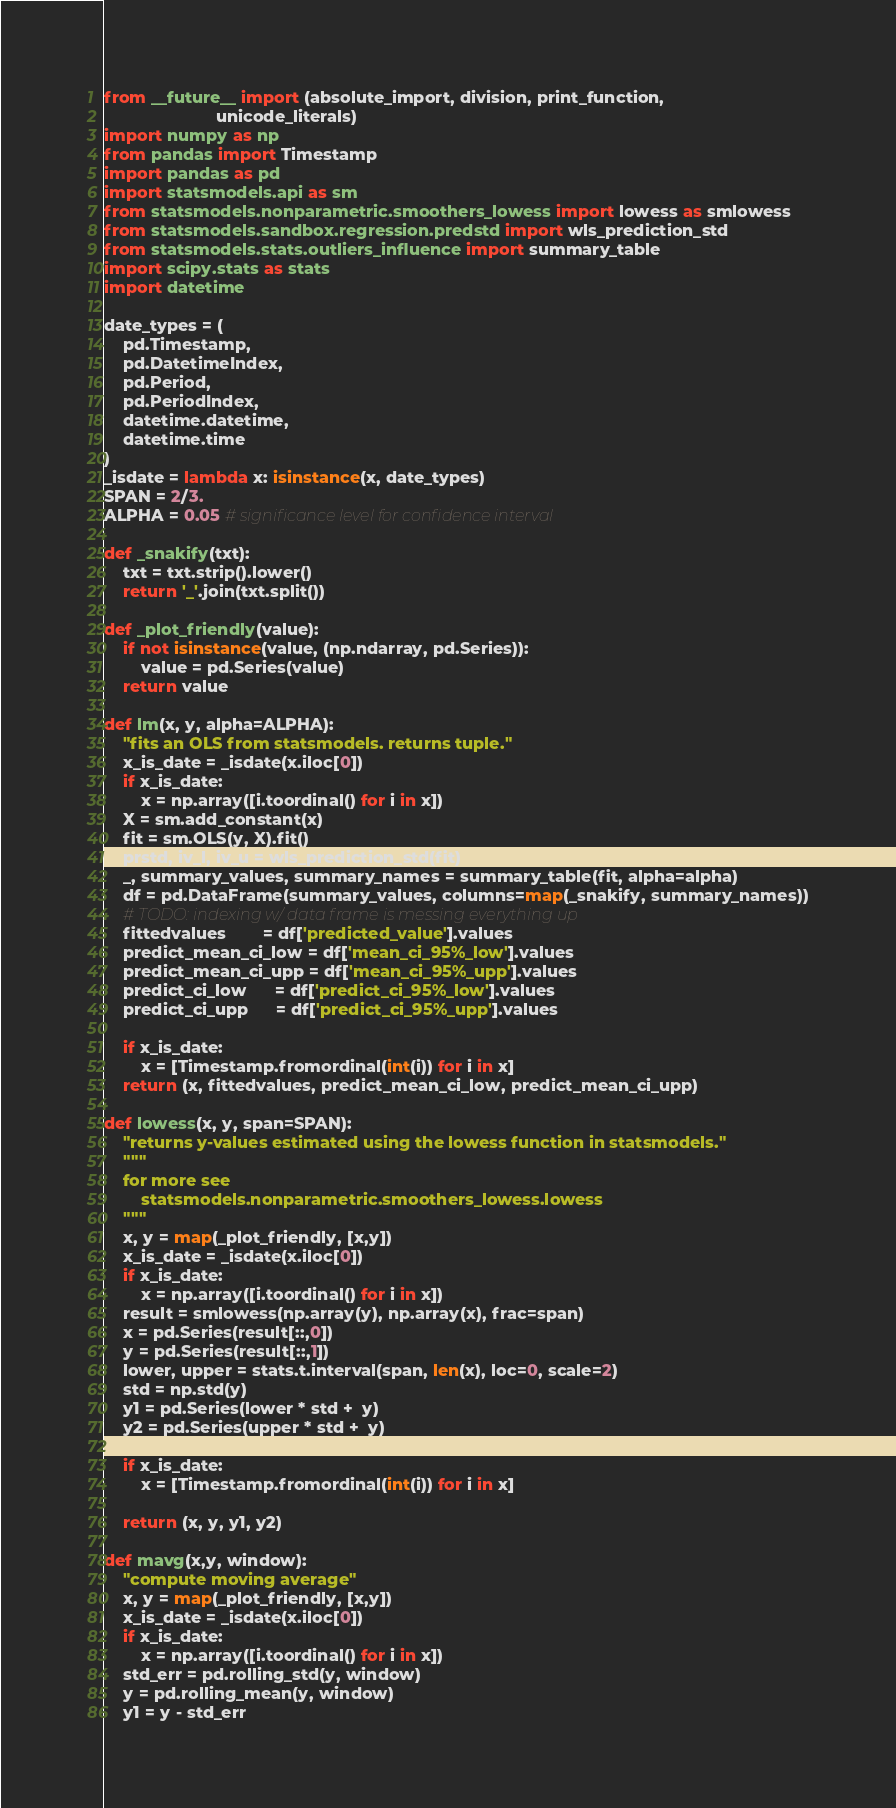Convert code to text. <code><loc_0><loc_0><loc_500><loc_500><_Python_>from __future__ import (absolute_import, division, print_function,
                        unicode_literals)
import numpy as np
from pandas import Timestamp
import pandas as pd
import statsmodels.api as sm
from statsmodels.nonparametric.smoothers_lowess import lowess as smlowess
from statsmodels.sandbox.regression.predstd import wls_prediction_std
from statsmodels.stats.outliers_influence import summary_table
import scipy.stats as stats
import datetime

date_types = (
    pd.Timestamp,
    pd.DatetimeIndex,
    pd.Period,
    pd.PeriodIndex,
    datetime.datetime,
    datetime.time
)
_isdate = lambda x: isinstance(x, date_types)
SPAN = 2/3.
ALPHA = 0.05 # significance level for confidence interval

def _snakify(txt):
    txt = txt.strip().lower()
    return '_'.join(txt.split())

def _plot_friendly(value):
    if not isinstance(value, (np.ndarray, pd.Series)):
        value = pd.Series(value)
    return value

def lm(x, y, alpha=ALPHA):
    "fits an OLS from statsmodels. returns tuple."
    x_is_date = _isdate(x.iloc[0])
    if x_is_date:
        x = np.array([i.toordinal() for i in x])
    X = sm.add_constant(x)
    fit = sm.OLS(y, X).fit()
    prstd, iv_l, iv_u = wls_prediction_std(fit)
    _, summary_values, summary_names = summary_table(fit, alpha=alpha)
    df = pd.DataFrame(summary_values, columns=map(_snakify, summary_names))
    # TODO: indexing w/ data frame is messing everything up
    fittedvalues        = df['predicted_value'].values
    predict_mean_ci_low = df['mean_ci_95%_low'].values
    predict_mean_ci_upp = df['mean_ci_95%_upp'].values
    predict_ci_low      = df['predict_ci_95%_low'].values
    predict_ci_upp      = df['predict_ci_95%_upp'].values

    if x_is_date:
        x = [Timestamp.fromordinal(int(i)) for i in x]
    return (x, fittedvalues, predict_mean_ci_low, predict_mean_ci_upp)

def lowess(x, y, span=SPAN):
    "returns y-values estimated using the lowess function in statsmodels."
    """
    for more see
        statsmodels.nonparametric.smoothers_lowess.lowess
    """
    x, y = map(_plot_friendly, [x,y])
    x_is_date = _isdate(x.iloc[0])
    if x_is_date:
        x = np.array([i.toordinal() for i in x])
    result = smlowess(np.array(y), np.array(x), frac=span)
    x = pd.Series(result[::,0])
    y = pd.Series(result[::,1])
    lower, upper = stats.t.interval(span, len(x), loc=0, scale=2)
    std = np.std(y)
    y1 = pd.Series(lower * std +  y)
    y2 = pd.Series(upper * std +  y)

    if x_is_date:
        x = [Timestamp.fromordinal(int(i)) for i in x]

    return (x, y, y1, y2)

def mavg(x,y, window):
    "compute moving average"
    x, y = map(_plot_friendly, [x,y])
    x_is_date = _isdate(x.iloc[0])
    if x_is_date:
        x = np.array([i.toordinal() for i in x])
    std_err = pd.rolling_std(y, window)
    y = pd.rolling_mean(y, window)
    y1 = y - std_err</code> 